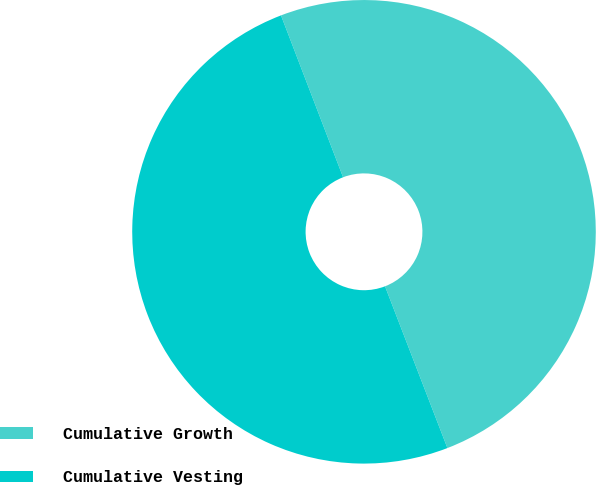<chart> <loc_0><loc_0><loc_500><loc_500><pie_chart><fcel>Cumulative Growth<fcel>Cumulative Vesting<nl><fcel>49.97%<fcel>50.03%<nl></chart> 